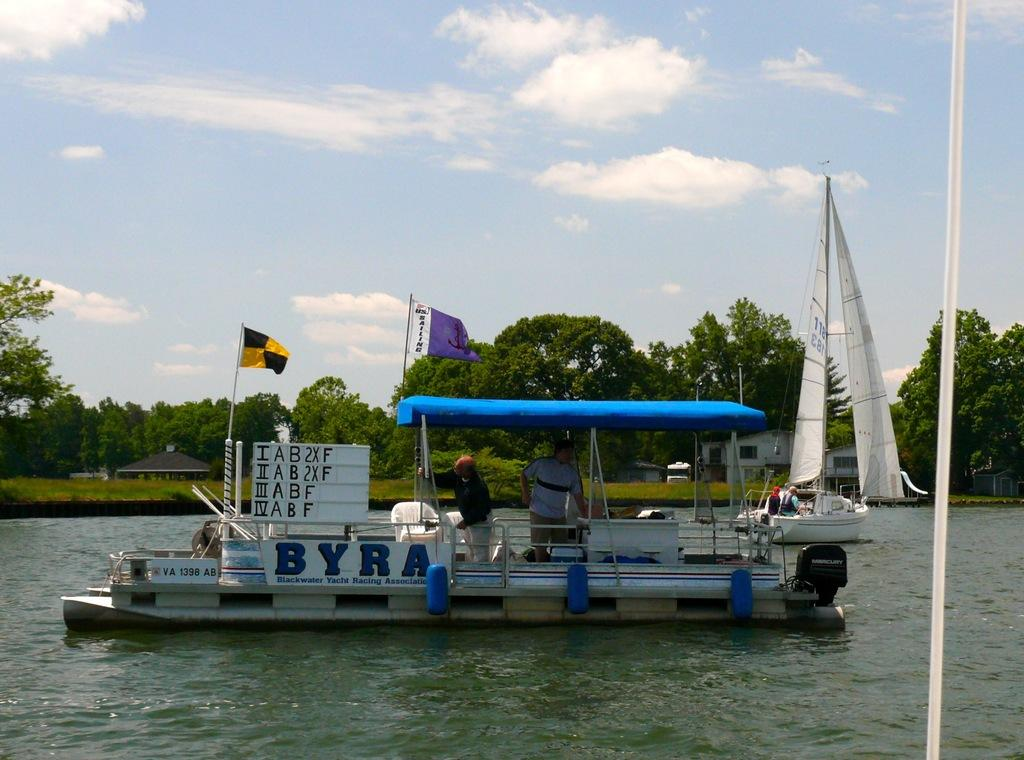<image>
Give a short and clear explanation of the subsequent image. A boat that says BYRA on the side is flying a black and yellow flag. 